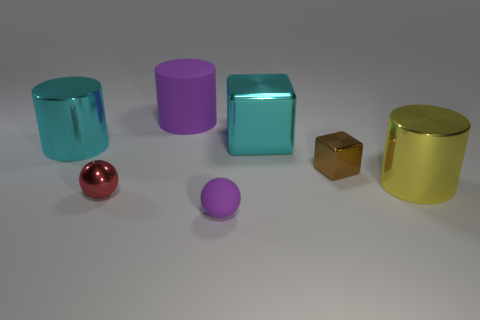Is the color of the tiny object that is in front of the tiny red shiny ball the same as the big cylinder behind the big cyan cylinder?
Offer a terse response. Yes. What is the size of the cube that is in front of the large metal thing left of the purple matte object that is behind the tiny rubber object?
Provide a succinct answer. Small. What color is the other large metal object that is the same shape as the yellow shiny object?
Keep it short and to the point. Cyan. Is the number of yellow shiny things to the left of the small brown object greater than the number of blue shiny objects?
Offer a very short reply. No. There is a tiny red thing; is its shape the same as the large cyan shiny object that is behind the cyan metal cylinder?
Offer a terse response. No. Is there any other thing that is the same size as the brown thing?
Provide a short and direct response. Yes. What is the size of the purple rubber object that is the same shape as the red metal thing?
Provide a succinct answer. Small. Is the number of yellow objects greater than the number of large objects?
Your answer should be compact. No. Does the yellow thing have the same shape as the small brown metallic thing?
Your response must be concise. No. There is a big cyan thing behind the large cylinder on the left side of the big purple object; what is its material?
Ensure brevity in your answer.  Metal. 